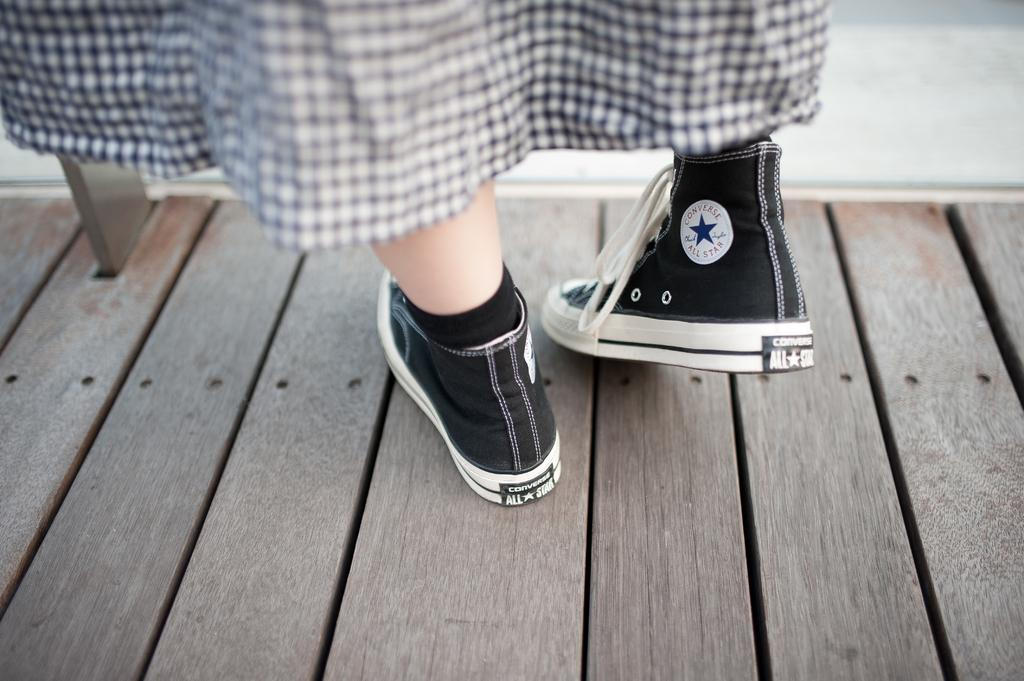What is present in the image? There is a person in the image. What part of the person's body can be seen in the image? The person's legs are visible in the image. What type of clothing is the person wearing on their legs? The person is wearing shoes in the image. What type of clothing is the person wearing on their upper body? The person is wearing a dress in the image. What type of surface is at the bottom portion of the image? There is a wooden surface at the bottom portion of the image. What is the price of the heart-shaped pendant in the image? There is no heart-shaped pendant present in the image. 